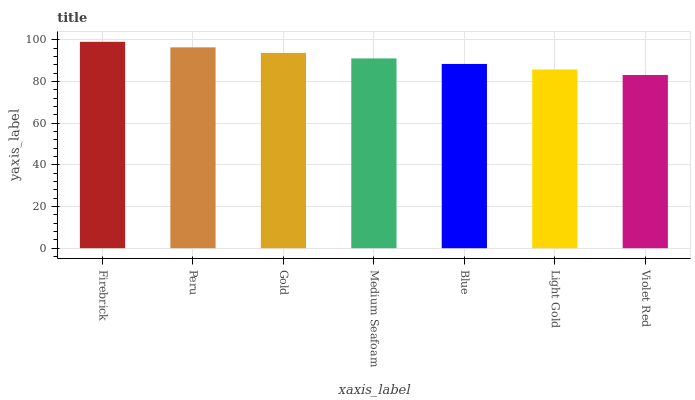Is Violet Red the minimum?
Answer yes or no. Yes. Is Firebrick the maximum?
Answer yes or no. Yes. Is Peru the minimum?
Answer yes or no. No. Is Peru the maximum?
Answer yes or no. No. Is Firebrick greater than Peru?
Answer yes or no. Yes. Is Peru less than Firebrick?
Answer yes or no. Yes. Is Peru greater than Firebrick?
Answer yes or no. No. Is Firebrick less than Peru?
Answer yes or no. No. Is Medium Seafoam the high median?
Answer yes or no. Yes. Is Medium Seafoam the low median?
Answer yes or no. Yes. Is Gold the high median?
Answer yes or no. No. Is Violet Red the low median?
Answer yes or no. No. 